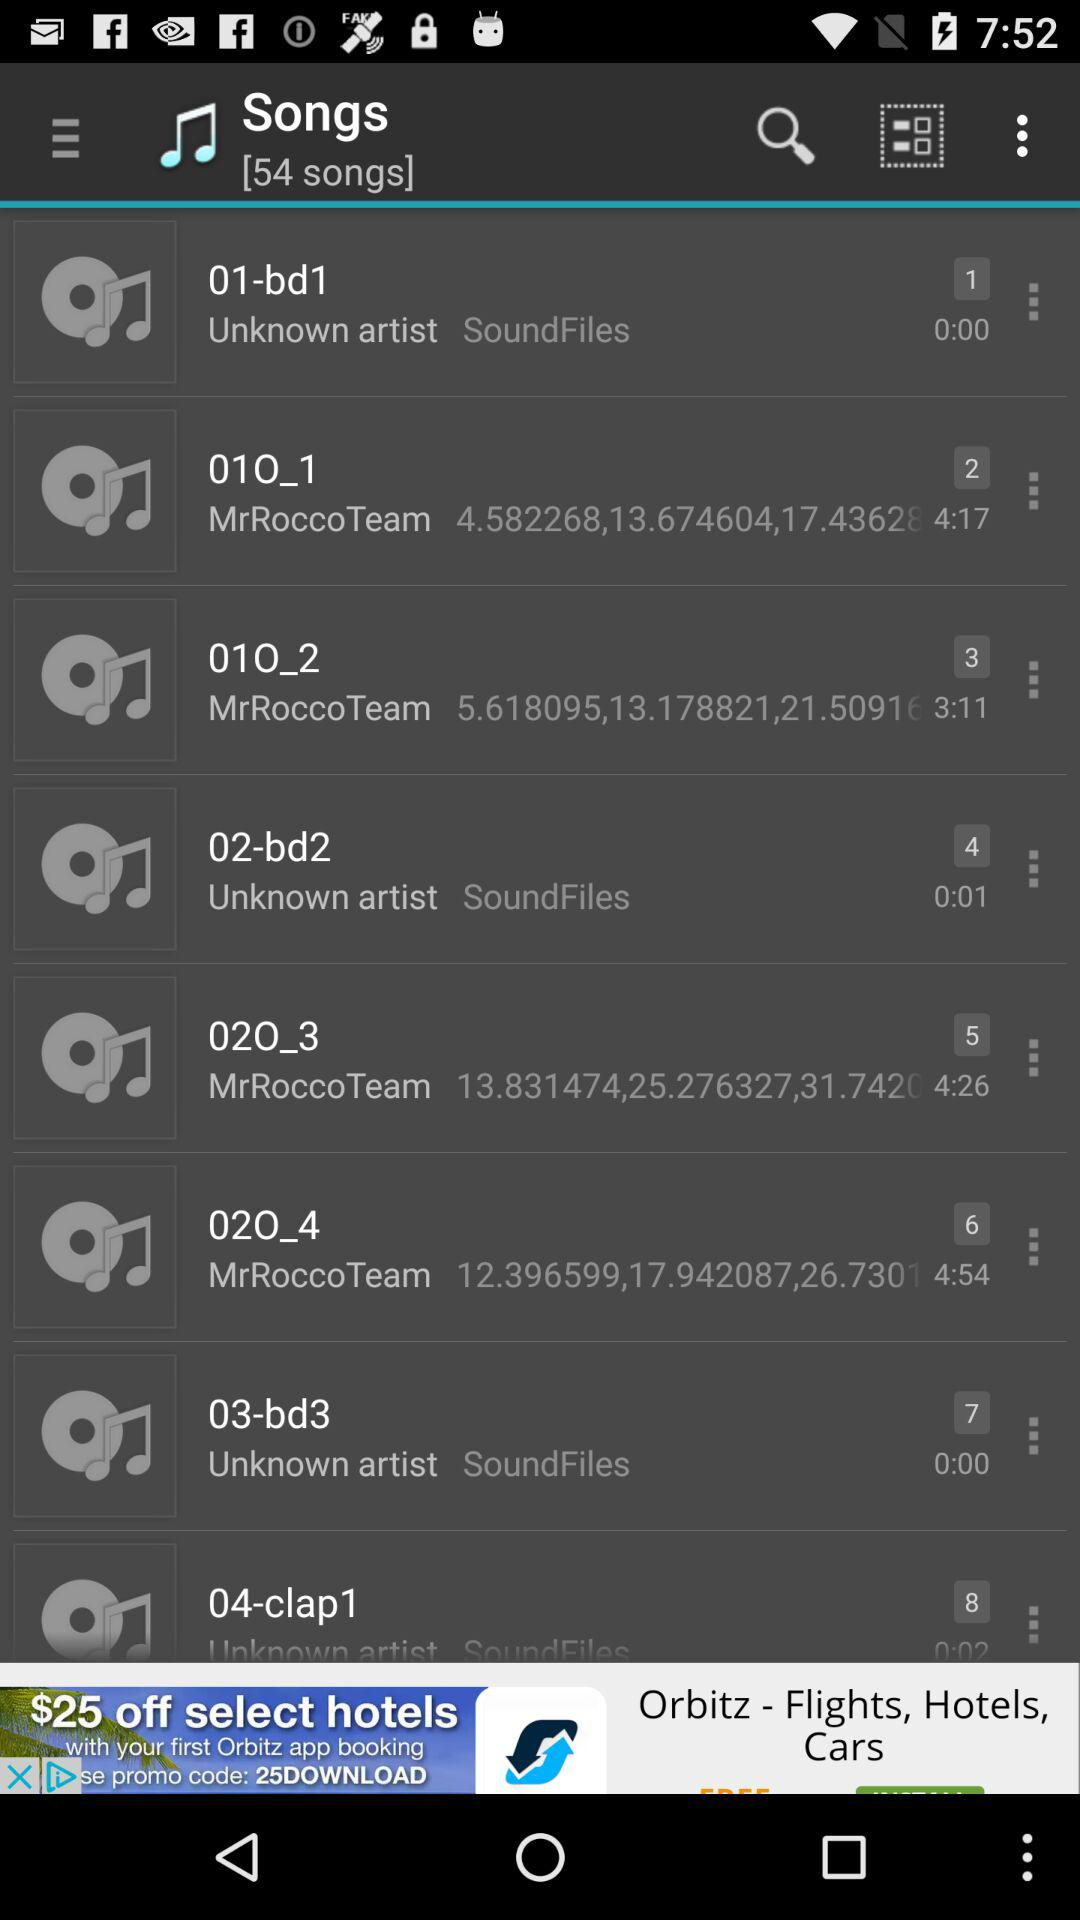What is the number of songs? The number of songs is 54. 